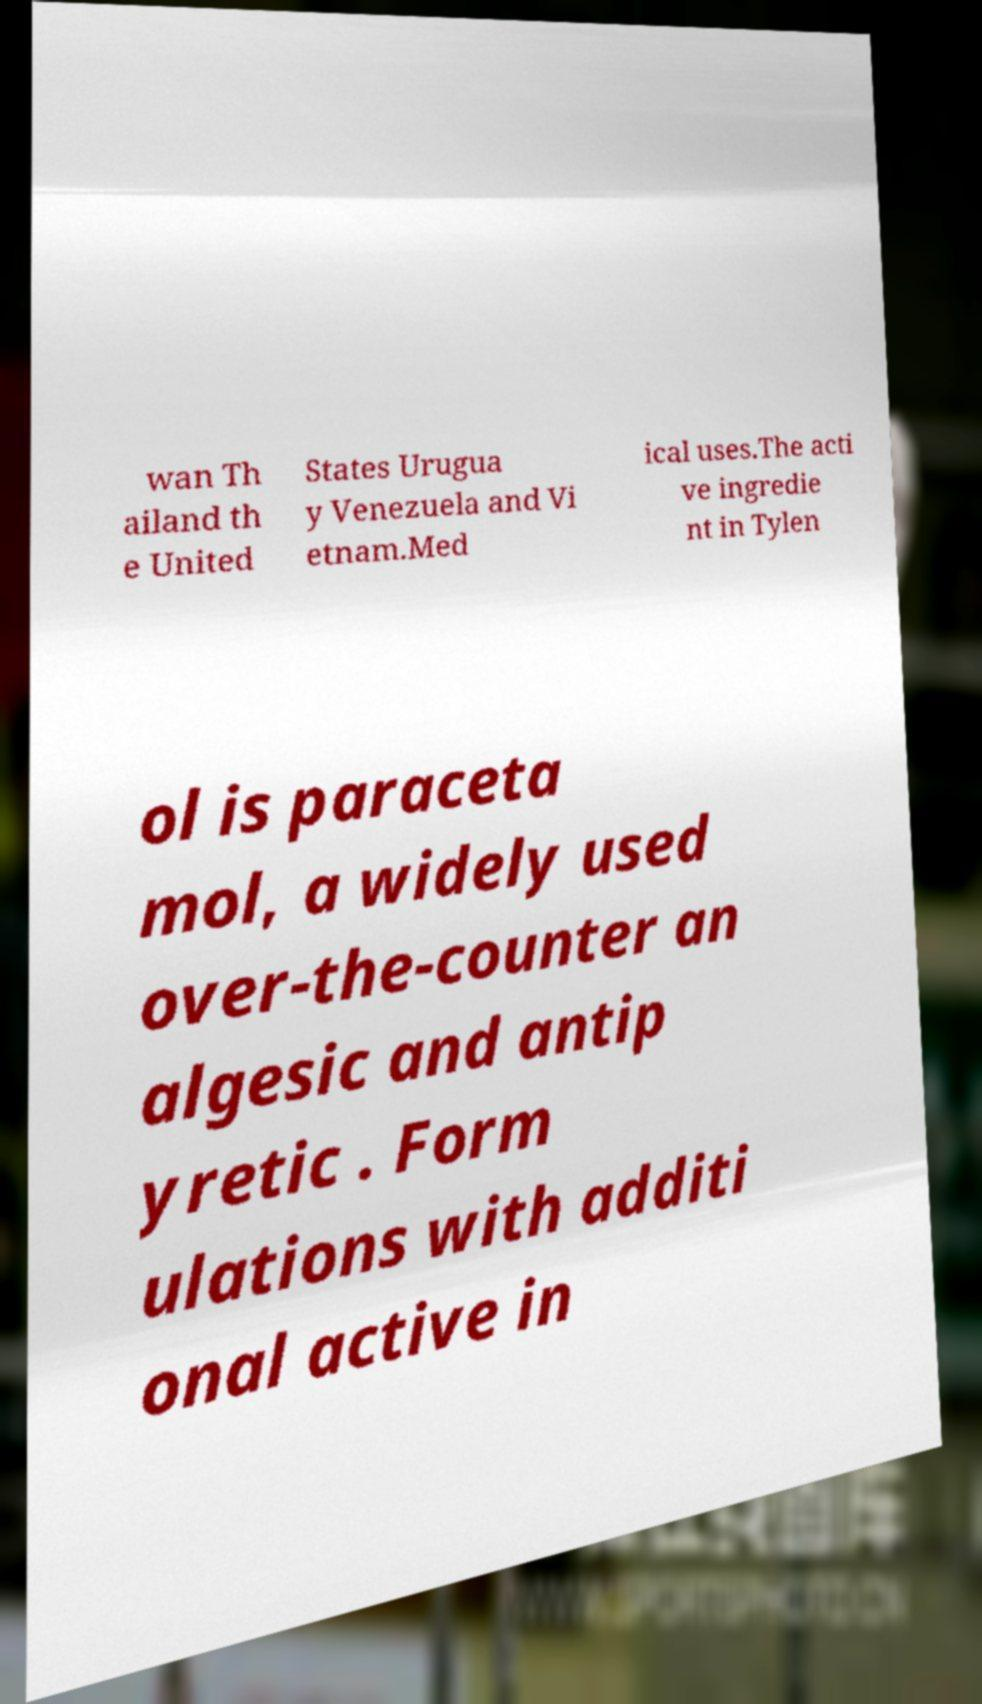Could you extract and type out the text from this image? wan Th ailand th e United States Urugua y Venezuela and Vi etnam.Med ical uses.The acti ve ingredie nt in Tylen ol is paraceta mol, a widely used over-the-counter an algesic and antip yretic . Form ulations with additi onal active in 